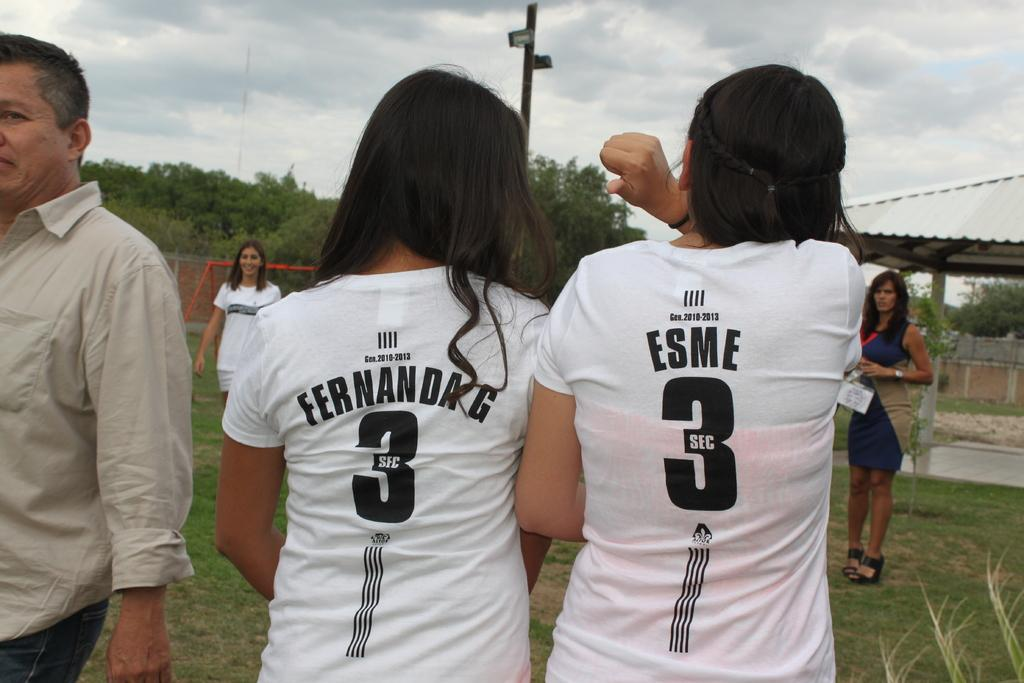<image>
Relay a brief, clear account of the picture shown. Two females in matching shirts that say 3 Sec and their last names. 